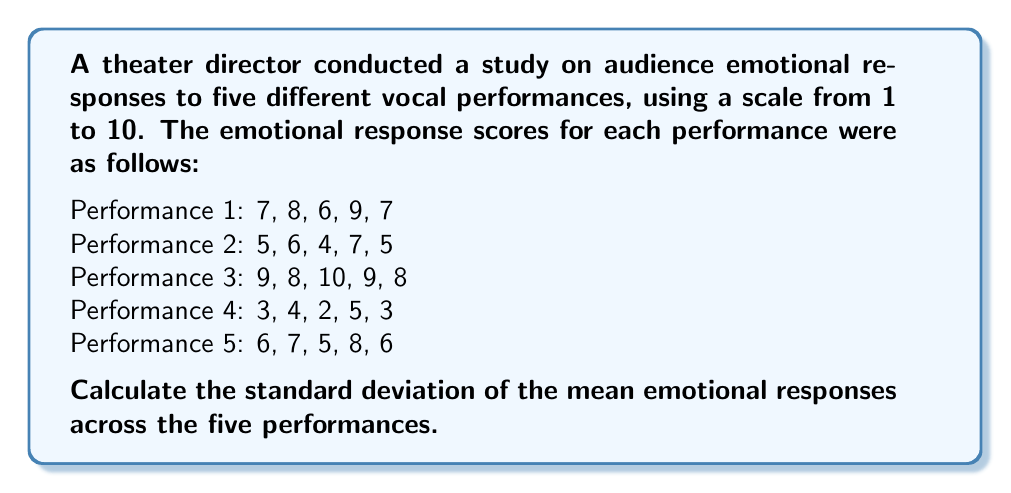What is the answer to this math problem? To calculate the standard deviation of the mean emotional responses, we'll follow these steps:

1. Calculate the mean emotional response for each performance:
   Performance 1: $\frac{7 + 8 + 6 + 9 + 7}{5} = 7.4$
   Performance 2: $\frac{5 + 6 + 4 + 7 + 5}{5} = 5.4$
   Performance 3: $\frac{9 + 8 + 10 + 9 + 8}{5} = 8.8$
   Performance 4: $\frac{3 + 4 + 2 + 5 + 3}{5} = 3.4$
   Performance 5: $\frac{6 + 7 + 5 + 8 + 6}{5} = 6.4$

2. Calculate the mean of these means:
   $\bar{x} = \frac{7.4 + 5.4 + 8.8 + 3.4 + 6.4}{5} = 6.28$

3. Calculate the squared differences from the mean:
   $(7.4 - 6.28)^2 = 1.2544$
   $(5.4 - 6.28)^2 = 0.7744$
   $(8.8 - 6.28)^2 = 6.3504$
   $(3.4 - 6.28)^2 = 8.2944$
   $(6.4 - 6.28)^2 = 0.0144$

4. Calculate the variance:
   $s^2 = \frac{1.2544 + 0.7744 + 6.3504 + 8.2944 + 0.0144}{5 - 1} = 4.1720$

5. Calculate the standard deviation:
   $s = \sqrt{4.1720} = 2.0425$

Therefore, the standard deviation of the mean emotional responses is approximately 2.0425.
Answer: $2.0425$ 